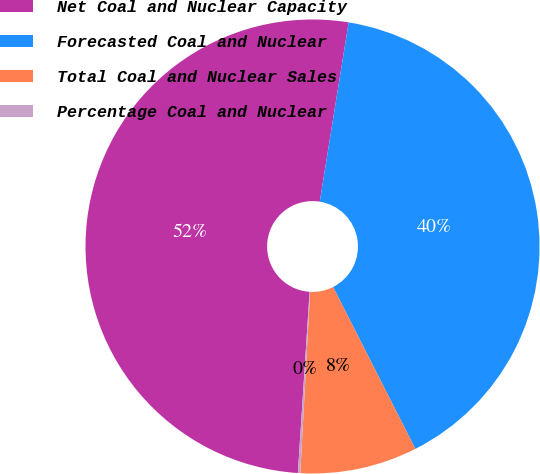Convert chart. <chart><loc_0><loc_0><loc_500><loc_500><pie_chart><fcel>Net Coal and Nuclear Capacity<fcel>Forecasted Coal and Nuclear<fcel>Total Coal and Nuclear Sales<fcel>Percentage Coal and Nuclear<nl><fcel>51.52%<fcel>39.98%<fcel>8.34%<fcel>0.17%<nl></chart> 